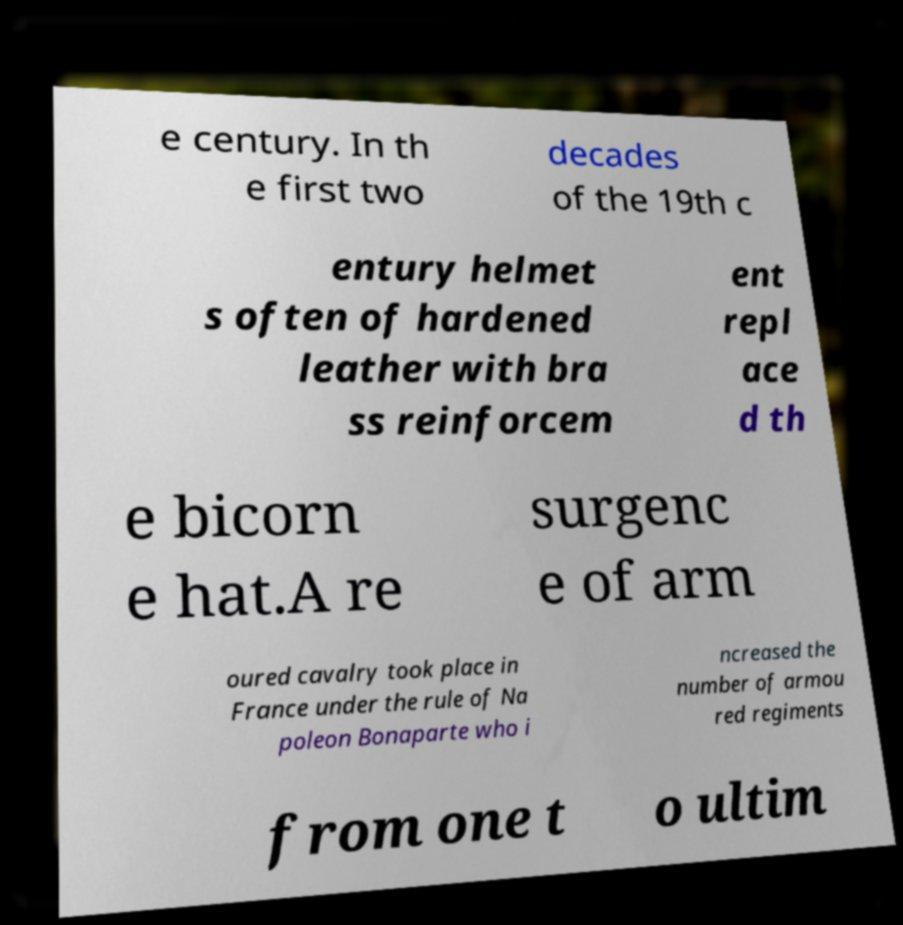Please read and relay the text visible in this image. What does it say? e century. In th e first two decades of the 19th c entury helmet s often of hardened leather with bra ss reinforcem ent repl ace d th e bicorn e hat.A re surgenc e of arm oured cavalry took place in France under the rule of Na poleon Bonaparte who i ncreased the number of armou red regiments from one t o ultim 